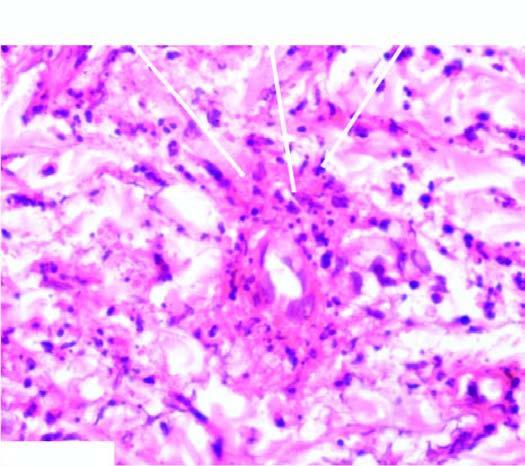what does the vessel wall show?
Answer the question using a single word or phrase. Fibrinoid necrosis surrounded by viable as well as fragmented neutrophils 